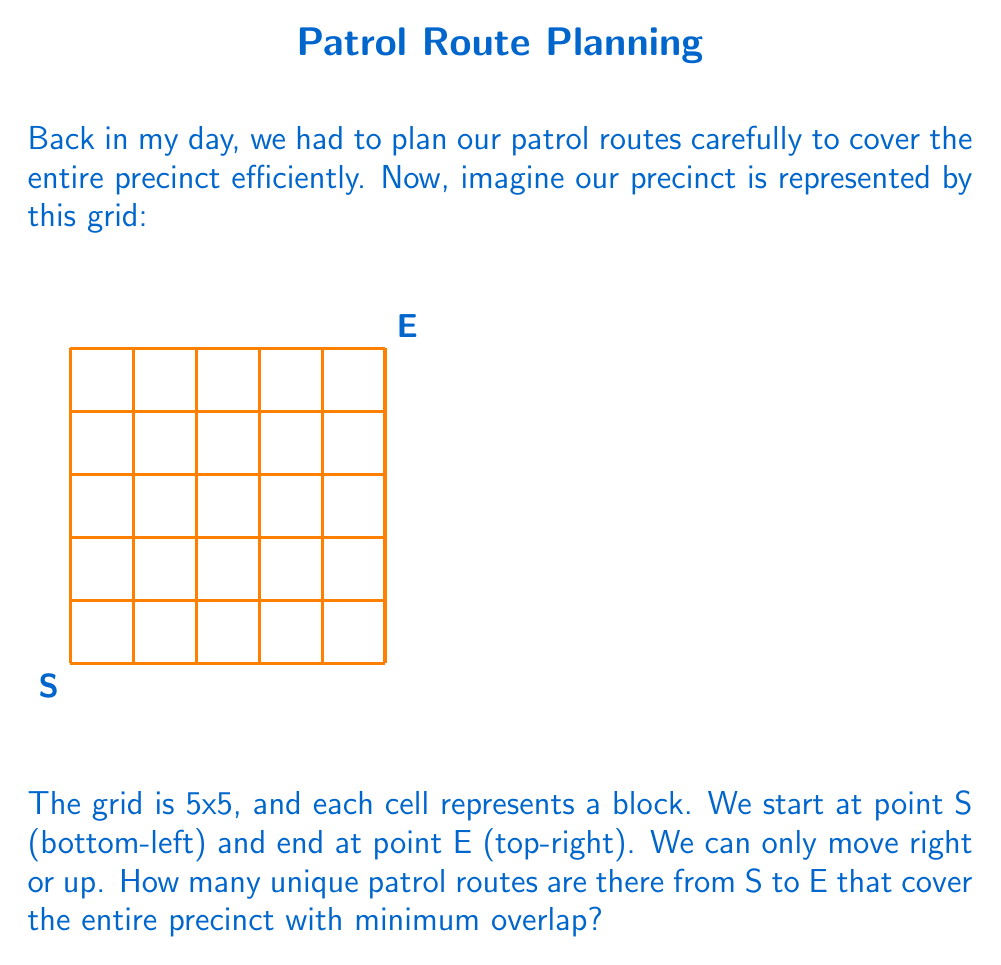Give your solution to this math problem. Let's approach this step-by-step:

1) First, we need to understand what constitutes a minimum overlap route. In this case, it means we need to reach E from S in the least number of steps possible.

2) To go from S to E, we always need to move 5 steps right and 5 steps up, regardless of the order. This ensures we cover the entire precinct with minimum overlap.

3) The total number of steps is always 10 (5 right + 5 up).

4) This problem is equivalent to choosing when to make the 5 upward moves out of the 10 total moves (or equivalently, when to make the 5 rightward moves).

5) In mathematical terms, this is a combination problem. We're selecting 5 positions out of 10 for the upward moves (or rightward moves).

6) The formula for this combination is:

   $$\binom{10}{5} = \frac{10!}{5!(10-5)!} = \frac{10!}{5!5!}$$

7) Let's calculate this:
   $$\frac{10 * 9 * 8 * 7 * 6 * 5!}{5! * 5 * 4 * 3 * 2 * 1}$$

8) The 5! cancels out in the numerator and denominator:
   $$\frac{10 * 9 * 8 * 7 * 6}{5 * 4 * 3 * 2 * 1} = \frac{30240}{120} = 252$$

Therefore, there are 252 unique patrol routes from S to E that cover the entire precinct with minimum overlap.
Answer: 252 